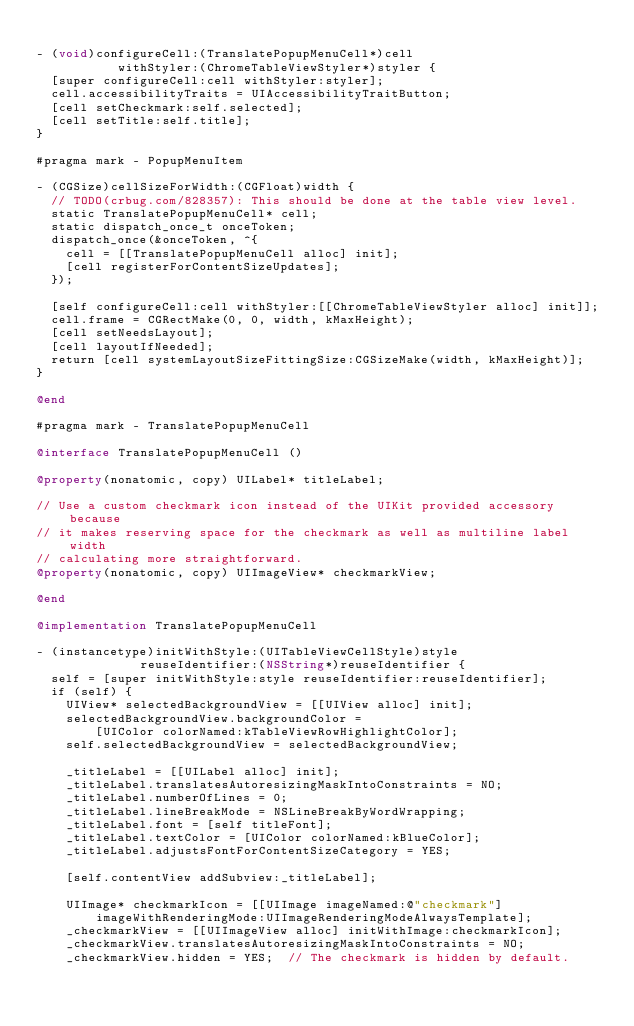Convert code to text. <code><loc_0><loc_0><loc_500><loc_500><_ObjectiveC_>
- (void)configureCell:(TranslatePopupMenuCell*)cell
           withStyler:(ChromeTableViewStyler*)styler {
  [super configureCell:cell withStyler:styler];
  cell.accessibilityTraits = UIAccessibilityTraitButton;
  [cell setCheckmark:self.selected];
  [cell setTitle:self.title];
}

#pragma mark - PopupMenuItem

- (CGSize)cellSizeForWidth:(CGFloat)width {
  // TODO(crbug.com/828357): This should be done at the table view level.
  static TranslatePopupMenuCell* cell;
  static dispatch_once_t onceToken;
  dispatch_once(&onceToken, ^{
    cell = [[TranslatePopupMenuCell alloc] init];
    [cell registerForContentSizeUpdates];
  });

  [self configureCell:cell withStyler:[[ChromeTableViewStyler alloc] init]];
  cell.frame = CGRectMake(0, 0, width, kMaxHeight);
  [cell setNeedsLayout];
  [cell layoutIfNeeded];
  return [cell systemLayoutSizeFittingSize:CGSizeMake(width, kMaxHeight)];
}

@end

#pragma mark - TranslatePopupMenuCell

@interface TranslatePopupMenuCell ()

@property(nonatomic, copy) UILabel* titleLabel;

// Use a custom checkmark icon instead of the UIKit provided accessory because
// it makes reserving space for the checkmark as well as multiline label width
// calculating more straightforward.
@property(nonatomic, copy) UIImageView* checkmarkView;

@end

@implementation TranslatePopupMenuCell

- (instancetype)initWithStyle:(UITableViewCellStyle)style
              reuseIdentifier:(NSString*)reuseIdentifier {
  self = [super initWithStyle:style reuseIdentifier:reuseIdentifier];
  if (self) {
    UIView* selectedBackgroundView = [[UIView alloc] init];
    selectedBackgroundView.backgroundColor =
        [UIColor colorNamed:kTableViewRowHighlightColor];
    self.selectedBackgroundView = selectedBackgroundView;

    _titleLabel = [[UILabel alloc] init];
    _titleLabel.translatesAutoresizingMaskIntoConstraints = NO;
    _titleLabel.numberOfLines = 0;
    _titleLabel.lineBreakMode = NSLineBreakByWordWrapping;
    _titleLabel.font = [self titleFont];
    _titleLabel.textColor = [UIColor colorNamed:kBlueColor];
    _titleLabel.adjustsFontForContentSizeCategory = YES;

    [self.contentView addSubview:_titleLabel];

    UIImage* checkmarkIcon = [[UIImage imageNamed:@"checkmark"]
        imageWithRenderingMode:UIImageRenderingModeAlwaysTemplate];
    _checkmarkView = [[UIImageView alloc] initWithImage:checkmarkIcon];
    _checkmarkView.translatesAutoresizingMaskIntoConstraints = NO;
    _checkmarkView.hidden = YES;  // The checkmark is hidden by default.
</code> 